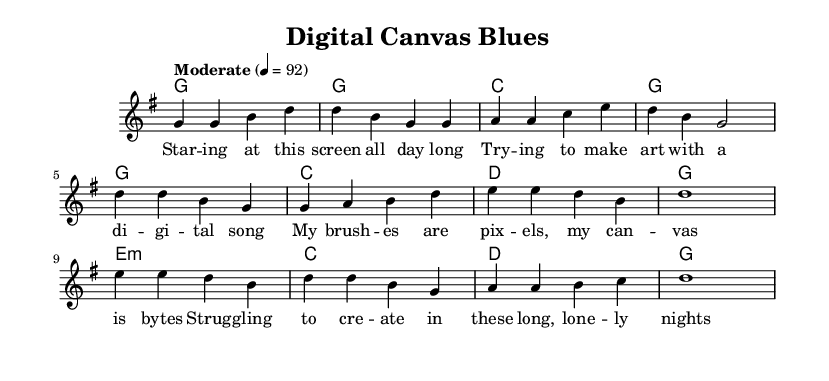What is the key signature of this music? The key signature is G major, which has one sharp (F#). This can be determined by looking at the key signature indicated at the beginning of the score.
Answer: G major What is the time signature of this piece? The time signature is 4/4, as indicated at the beginning of the music. This signature means there are four beats per measure and it is a common time signature in many styles, including country music.
Answer: 4/4 What is the tempo marking of the piece? The tempo marking is "Moderate" with a specific metronome marking of 92 beats per minute. This information is directly mentioned in the tempo indication in the score.
Answer: Moderate 92 How many measures are in the verse section? The verse section consists of four measures, which can be counted by looking at the section of the melody that is labeled as "Verse" in the music.
Answer: Four What chords are used in the chorus? The chords used in the chorus are G, C, D, and G. These are identified by looking at the chord symbols written above the melody in the chorus section of the music.
Answer: G, C, D, G What theme is explored in the lyrics of this song? The theme explored in the lyrics is the struggles of creating art in a digital age, specifically reflecting on student life and academic pressure. This is evident from the lyrics describing loneliness and the quest for inspiration while working with technology.
Answer: Struggles of creating art How does the bridge section contribute to the overall message of the song? The bridge section offers a sense of hope, emphasizing perseverance and finding one's voice amidst the challenges. It contrasts with the verse's struggles by suggesting that despite difficulties, the speaker will continue to create and adapt. This thematic element enriches the song’s narrative.
Answer: Sense of hope 